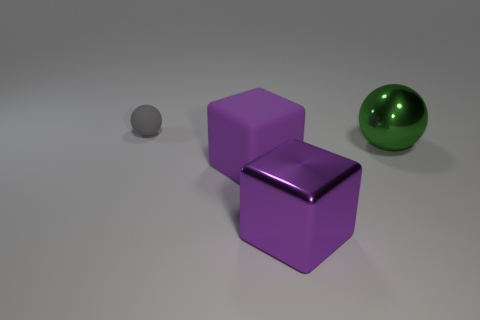Is there any other thing that has the same size as the gray sphere?
Your answer should be compact. No. There is another block that is the same color as the metallic cube; what material is it?
Your answer should be compact. Rubber. What size is the shiny cube that is the same color as the rubber block?
Provide a short and direct response. Large. What number of purple things are made of the same material as the tiny sphere?
Ensure brevity in your answer.  1. Are any gray objects visible?
Your answer should be very brief. Yes. There is a object that is left of the purple rubber block; what size is it?
Provide a succinct answer. Small. How many shiny objects have the same color as the big ball?
Give a very brief answer. 0. What number of blocks are tiny gray metal objects or big things?
Your response must be concise. 2. There is a thing that is on the right side of the large purple matte block and behind the big purple rubber object; what is its shape?
Provide a succinct answer. Sphere. Are there any cubes that have the same size as the purple metallic thing?
Provide a succinct answer. Yes. 